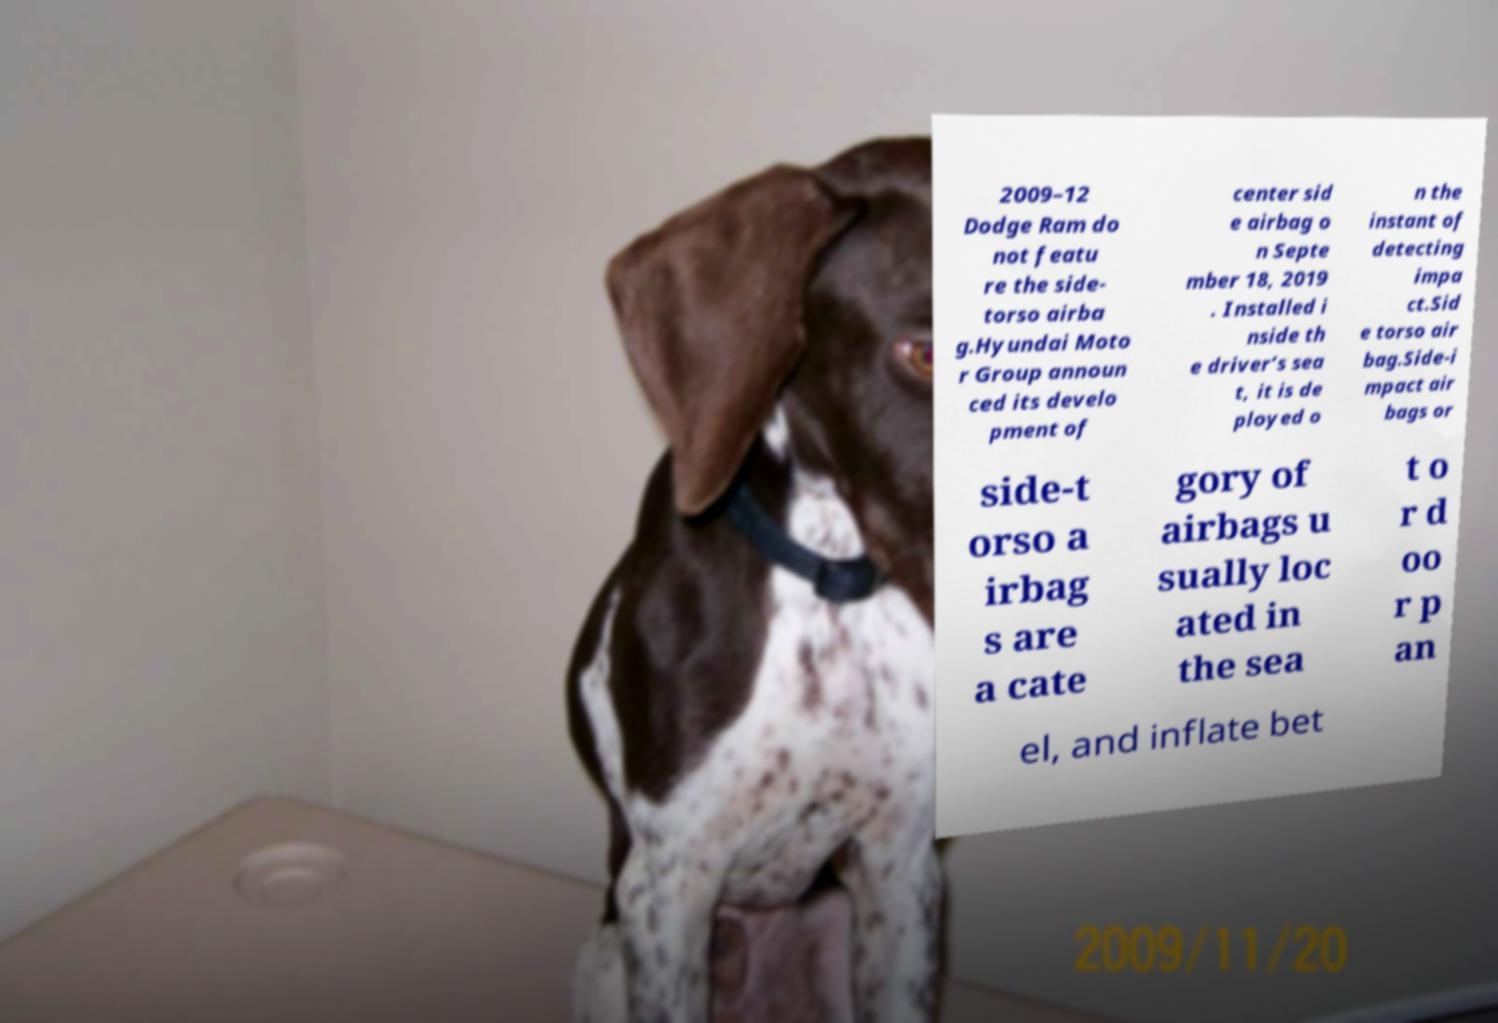Please read and relay the text visible in this image. What does it say? 2009–12 Dodge Ram do not featu re the side- torso airba g.Hyundai Moto r Group announ ced its develo pment of center sid e airbag o n Septe mber 18, 2019 . Installed i nside th e driver’s sea t, it is de ployed o n the instant of detecting impa ct.Sid e torso air bag.Side-i mpact air bags or side-t orso a irbag s are a cate gory of airbags u sually loc ated in the sea t o r d oo r p an el, and inflate bet 